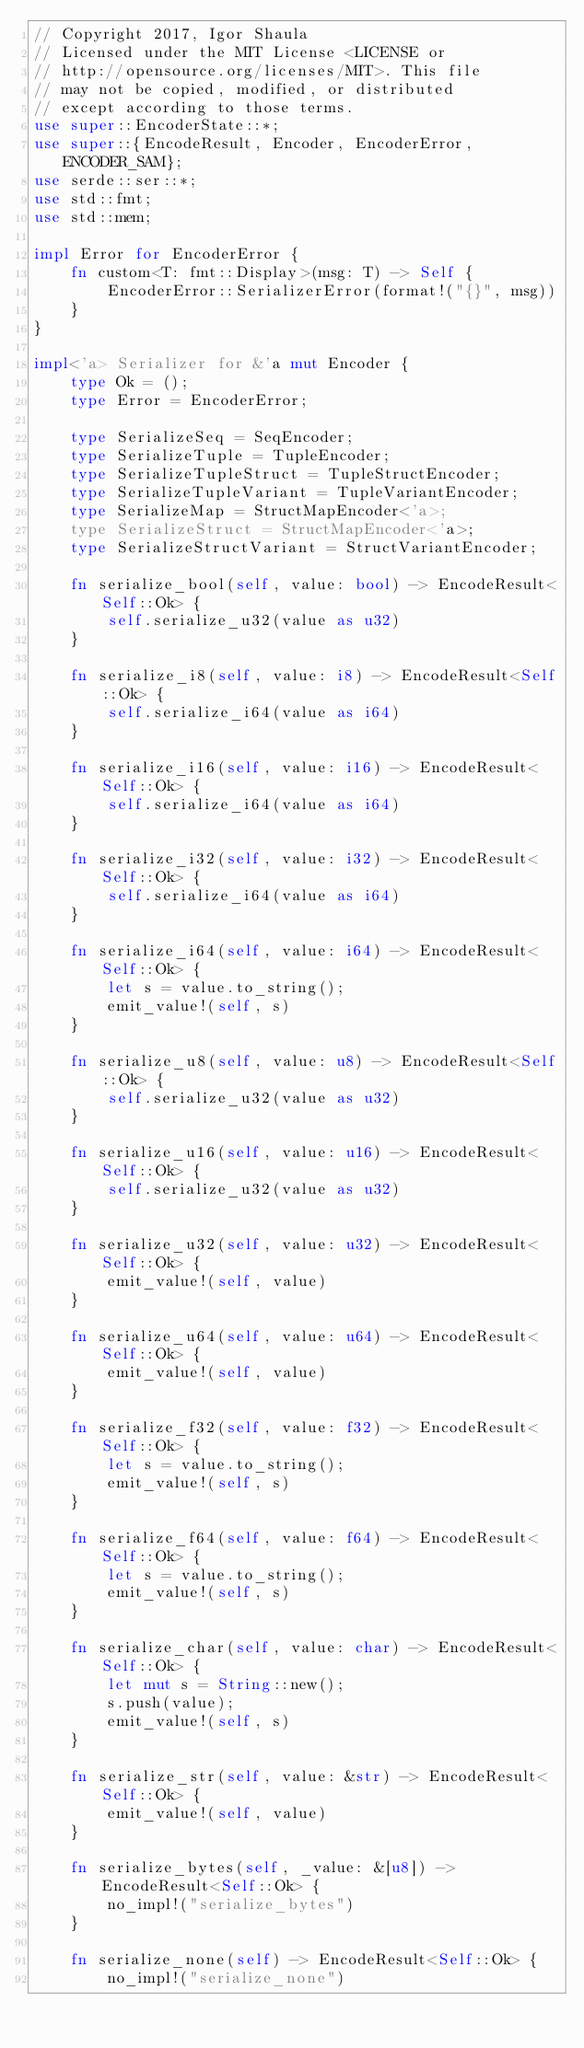<code> <loc_0><loc_0><loc_500><loc_500><_Rust_>// Copyright 2017, Igor Shaula
// Licensed under the MIT License <LICENSE or
// http://opensource.org/licenses/MIT>. This file
// may not be copied, modified, or distributed
// except according to those terms.
use super::EncoderState::*;
use super::{EncodeResult, Encoder, EncoderError, ENCODER_SAM};
use serde::ser::*;
use std::fmt;
use std::mem;

impl Error for EncoderError {
    fn custom<T: fmt::Display>(msg: T) -> Self {
        EncoderError::SerializerError(format!("{}", msg))
    }
}

impl<'a> Serializer for &'a mut Encoder {
    type Ok = ();
    type Error = EncoderError;

    type SerializeSeq = SeqEncoder;
    type SerializeTuple = TupleEncoder;
    type SerializeTupleStruct = TupleStructEncoder;
    type SerializeTupleVariant = TupleVariantEncoder;
    type SerializeMap = StructMapEncoder<'a>;
    type SerializeStruct = StructMapEncoder<'a>;
    type SerializeStructVariant = StructVariantEncoder;

    fn serialize_bool(self, value: bool) -> EncodeResult<Self::Ok> {
        self.serialize_u32(value as u32)
    }

    fn serialize_i8(self, value: i8) -> EncodeResult<Self::Ok> {
        self.serialize_i64(value as i64)
    }

    fn serialize_i16(self, value: i16) -> EncodeResult<Self::Ok> {
        self.serialize_i64(value as i64)
    }

    fn serialize_i32(self, value: i32) -> EncodeResult<Self::Ok> {
        self.serialize_i64(value as i64)
    }

    fn serialize_i64(self, value: i64) -> EncodeResult<Self::Ok> {
        let s = value.to_string();
        emit_value!(self, s)
    }

    fn serialize_u8(self, value: u8) -> EncodeResult<Self::Ok> {
        self.serialize_u32(value as u32)
    }

    fn serialize_u16(self, value: u16) -> EncodeResult<Self::Ok> {
        self.serialize_u32(value as u32)
    }

    fn serialize_u32(self, value: u32) -> EncodeResult<Self::Ok> {
        emit_value!(self, value)
    }

    fn serialize_u64(self, value: u64) -> EncodeResult<Self::Ok> {
        emit_value!(self, value)
    }

    fn serialize_f32(self, value: f32) -> EncodeResult<Self::Ok> {
        let s = value.to_string();
        emit_value!(self, s)
    }

    fn serialize_f64(self, value: f64) -> EncodeResult<Self::Ok> {
        let s = value.to_string();
        emit_value!(self, s)
    }

    fn serialize_char(self, value: char) -> EncodeResult<Self::Ok> {
        let mut s = String::new();
        s.push(value);
        emit_value!(self, s)
    }

    fn serialize_str(self, value: &str) -> EncodeResult<Self::Ok> {
        emit_value!(self, value)
    }

    fn serialize_bytes(self, _value: &[u8]) -> EncodeResult<Self::Ok> {
        no_impl!("serialize_bytes")
    }

    fn serialize_none(self) -> EncodeResult<Self::Ok> {
        no_impl!("serialize_none")</code> 